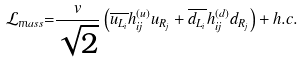<formula> <loc_0><loc_0><loc_500><loc_500>\mathcal { L } _ { \mathnormal m a s s } \mathnormal = \frac { v } { \sqrt { 2 } } \left ( \overline { u _ { L _ { i } } } h _ { i j } ^ { ( u ) } u _ { R _ { j } } + \overline { d _ { L _ { i } } } h _ { i j } ^ { ( d ) } d _ { R _ { j } } \right ) + h . c .</formula> 